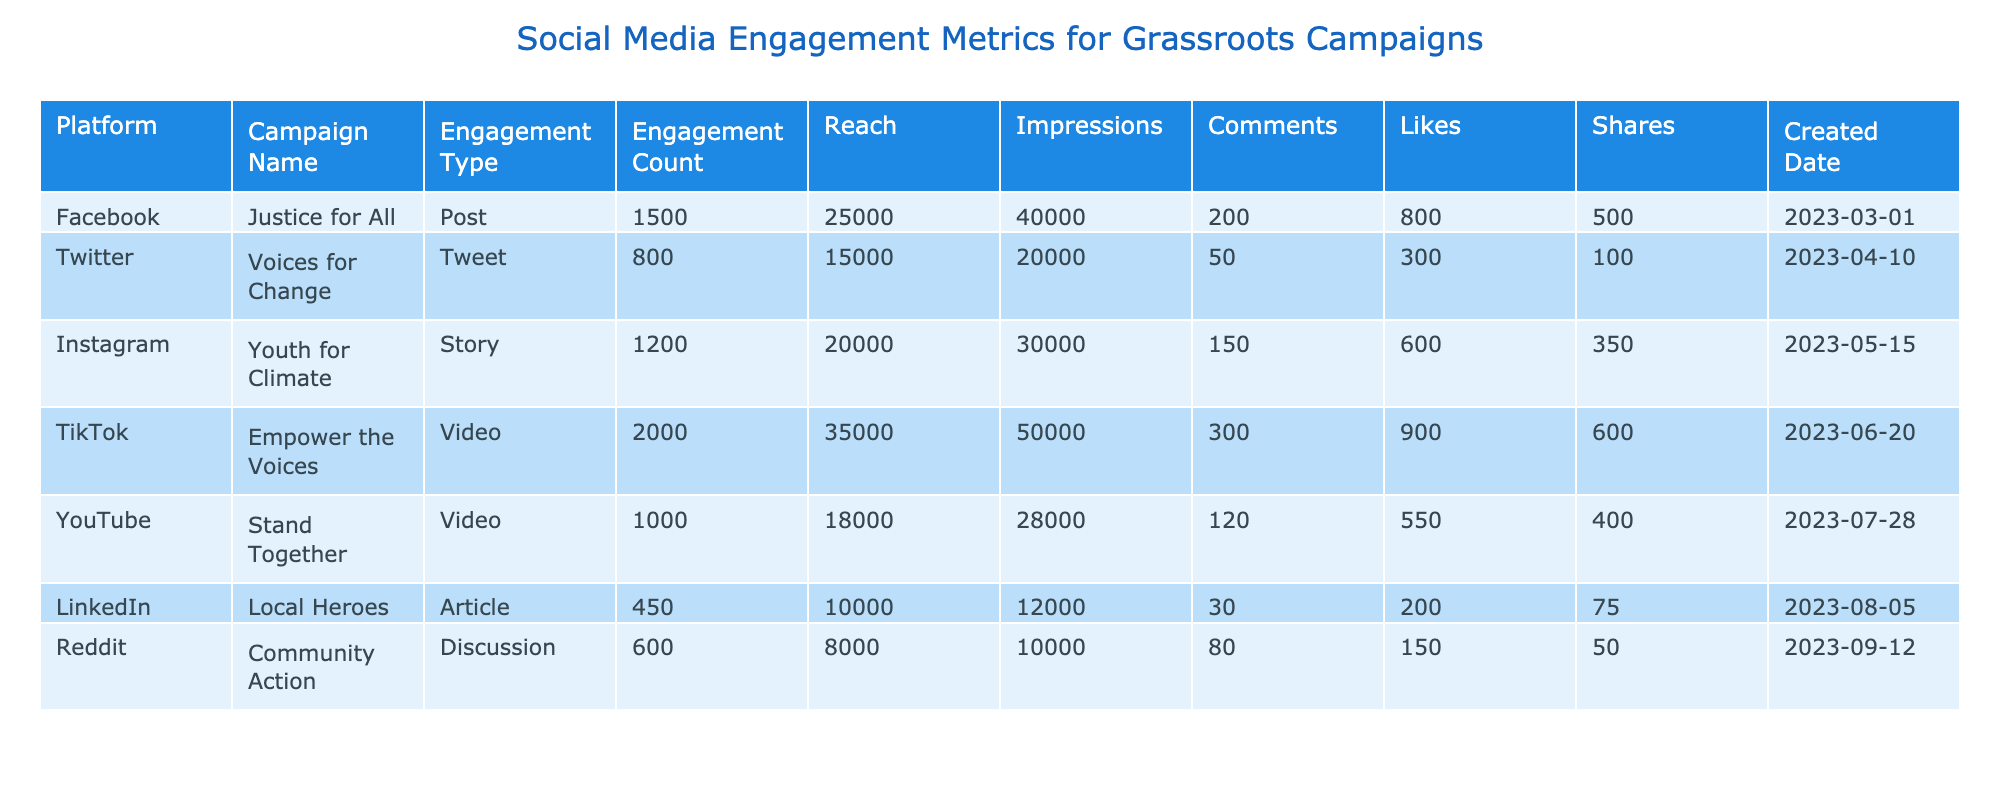What is the total engagement count for the "Justice for All" campaign? The engagement count for the "Justice for All" campaign is listed as 1500 in the table.
Answer: 1500 How many likes did the "Empower the Voices" TikTok video receive? In the table, it states that the "Empower the Voices" campaign received 900 likes.
Answer: 900 Which campaign had the highest reach, and what was that reach? By examining the reach column, the "Empower the Voices" campaign has the highest reach of 35000.
Answer: Empower the Voices, 35000 What is the difference in engagement count between the "Youth for Climate" and "Stand Together" campaigns? The "Youth for Climate" campaign has an engagement count of 1200 and the "Stand Together" campaign has 1000. The difference is calculated as 1200 - 1000 = 200.
Answer: 200 Did the "Local Heroes" campaign generate more shares than the "Community Action" discussion? The "Local Heroes" campaign had 75 shares, whereas the "Community Action" discussion had 50. Since 75 is greater than 50, the answer is yes.
Answer: Yes What is the average reach of all campaigns listed? To find the average, first add all the reach values: 25000 + 15000 + 20000 + 35000 + 18000 + 10000 + 8000 = 131000. Then divide by the number of campaigns (7), yielding an average reach of 131000/7 = 18714.29.
Answer: 18714.29 Which platform had the fewest comments? By inspecting the comments column, the "Local Heroes" article had the fewest comments at 30.
Answer: 30 How many total likes were received across all campaigns? The total likes can be summed from the table: 800 + 300 + 600 + 900 + 550 + 200 + 150 = 3500. Therefore, the total is 3500.
Answer: 3500 Was the engagement count for the "Voices for Change" campaign more than that of the "Stand Together" campaign? The "Voices for Change" campaign had an engagement count of 800 while "Stand Together" had 1000. Since 800 is less than 1000, the answer is no.
Answer: No 